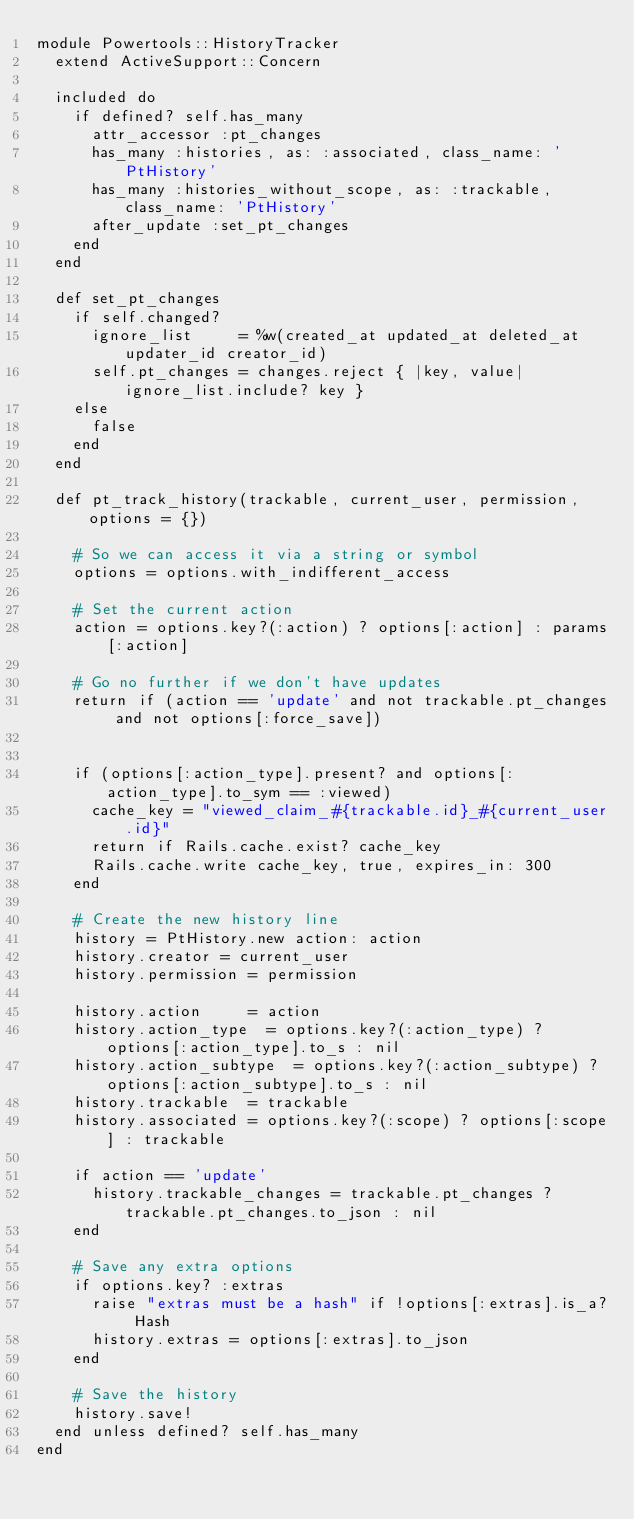Convert code to text. <code><loc_0><loc_0><loc_500><loc_500><_Ruby_>module Powertools::HistoryTracker
  extend ActiveSupport::Concern

  included do
    if defined? self.has_many
      attr_accessor :pt_changes
      has_many :histories, as: :associated, class_name: 'PtHistory'
      has_many :histories_without_scope, as: :trackable, class_name: 'PtHistory'
      after_update :set_pt_changes
    end
  end

  def set_pt_changes
    if self.changed?
      ignore_list     = %w(created_at updated_at deleted_at updater_id creator_id)
      self.pt_changes = changes.reject { |key, value| ignore_list.include? key }
    else
      false
    end
  end

  def pt_track_history(trackable, current_user, permission, options = {})

    # So we can access it via a string or symbol
    options = options.with_indifferent_access

    # Set the current action
    action = options.key?(:action) ? options[:action] : params[:action]

    # Go no further if we don't have updates
    return if (action == 'update' and not trackable.pt_changes and not options[:force_save])


    if (options[:action_type].present? and options[:action_type].to_sym == :viewed)
      cache_key = "viewed_claim_#{trackable.id}_#{current_user.id}"
      return if Rails.cache.exist? cache_key
      Rails.cache.write cache_key, true, expires_in: 300
    end

    # Create the new history line
    history = PtHistory.new action: action
    history.creator = current_user
    history.permission = permission

    history.action     = action
    history.action_type  = options.key?(:action_type) ? options[:action_type].to_s : nil
    history.action_subtype  = options.key?(:action_subtype) ? options[:action_subtype].to_s : nil
    history.trackable  = trackable
    history.associated = options.key?(:scope) ? options[:scope] : trackable

    if action == 'update'
      history.trackable_changes = trackable.pt_changes ? trackable.pt_changes.to_json : nil
    end

    # Save any extra options
    if options.key? :extras
      raise "extras must be a hash" if !options[:extras].is_a? Hash
      history.extras = options[:extras].to_json
    end

    # Save the history
    history.save!
  end unless defined? self.has_many
end
</code> 